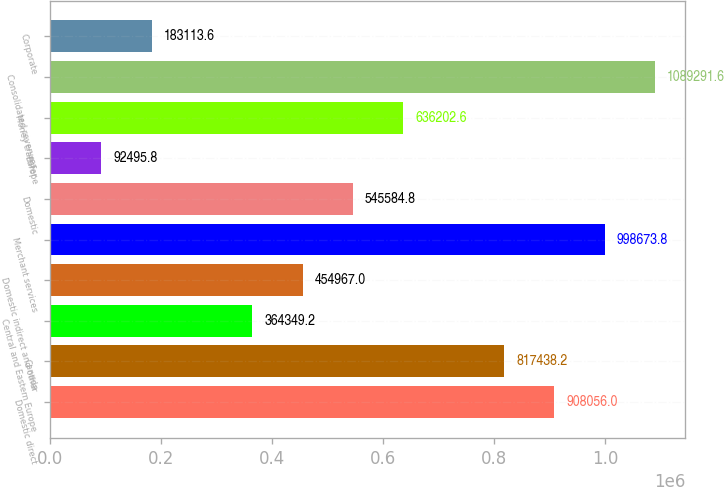Convert chart to OTSL. <chart><loc_0><loc_0><loc_500><loc_500><bar_chart><fcel>Domestic direct<fcel>Canada<fcel>Central and Eastern Europe<fcel>Domestic indirect and other<fcel>Merchant services<fcel>Domestic<fcel>Europe<fcel>Money transfer<fcel>Consolidated revenues<fcel>Corporate<nl><fcel>908056<fcel>817438<fcel>364349<fcel>454967<fcel>998674<fcel>545585<fcel>92495.8<fcel>636203<fcel>1.08929e+06<fcel>183114<nl></chart> 